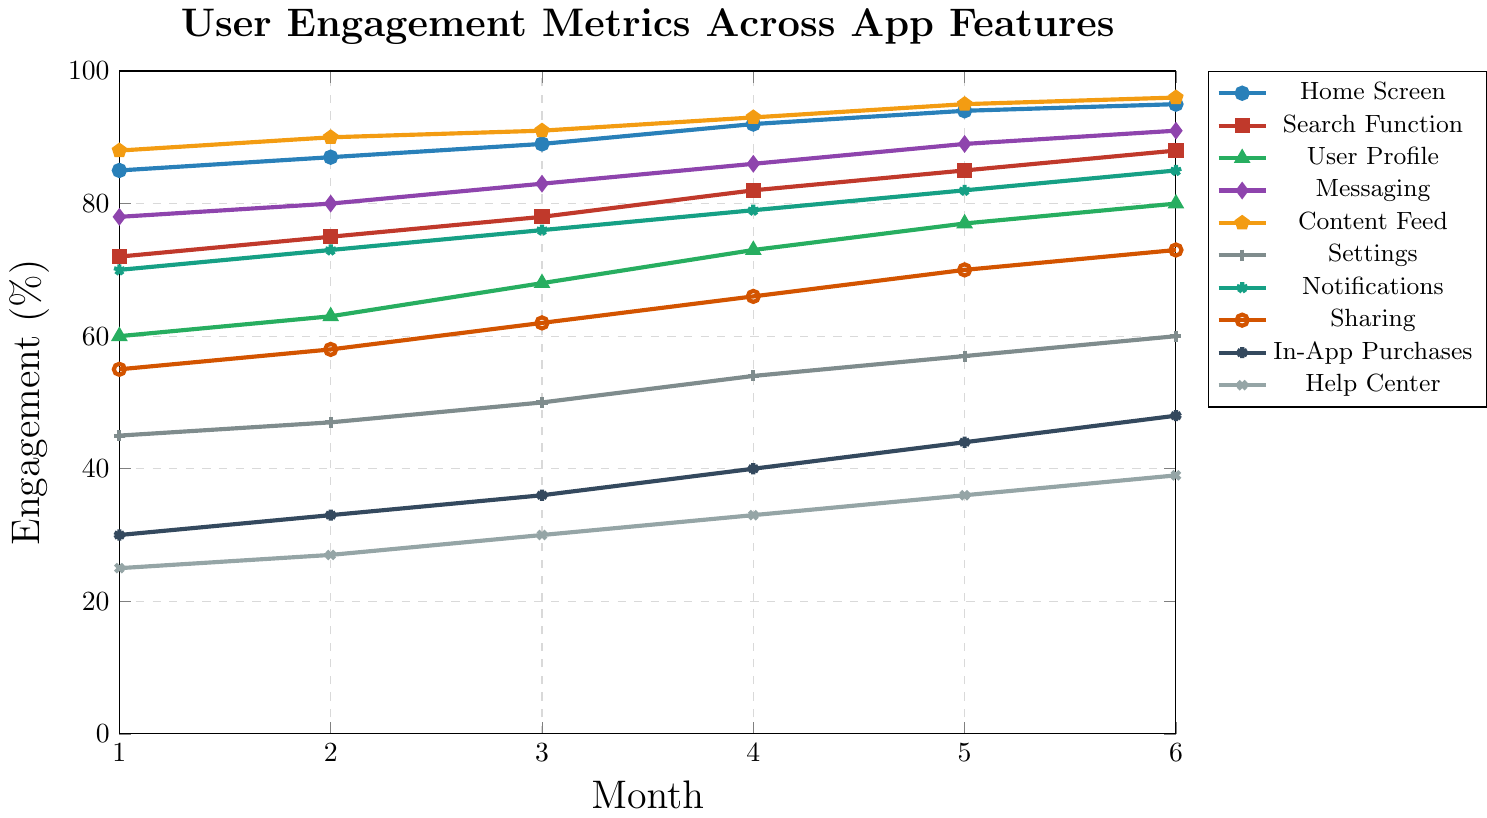What's the highest user engagement percentage recorded for any feature, and which feature does it belong to? The highest engagement percentage shown on the chart is 96%, which corresponds to the Content Feed feature in Month 6. To find this, look for the peak value on the y-axis and match it to the respective feature's line and month.
Answer: 96% Content Feed Which feature shows the largest absolute increase in user engagement from Month 1 to Month 6? To find the feature with the largest absolute increase, calculate the difference between Month 1 and Month 6 for each feature and identify the largest difference: Home Screen: 95-85=10, Search Function: 88-72=16, User Profile: 80-60=20, Messaging: 91-78=13, Content Feed: 96-88=8, Settings: 60-45=15, Notifications: 85-70=15, Sharing: 73-55=18, In-App Purchases: 48-30=18, Help Center: 39-25=14. The User Profile with 20% shows the largest increase.
Answer: User Profile Between Content Feed and Messaging, which feature had a higher user engagement percentage in Month 5, and by how much? Compare the values for Month 5: Content Feed has 95% and Messaging has 89%. Subtract the smaller value from the larger one: 95 - 89 = 6. Thus, Content Feed is higher by 6%.
Answer: Content Feed by 6% What is the average user engagement percentage for the Search function over the 6 months? To find the average, sum the engagement percentages for the Search Function over all 6 months and divide by 6. (72 + 75 + 78 + 82 + 85 + 88) / 6 = 480 / 6 = 80.
Answer: 80% Which feature consistently showed increasing user engagement every month, and what evidence supports this? The Search Function shows a continuous increase each month. Evidence: Month 1 = 72, Month 2 = 75, Month 3 = 78, Month 4 = 82, Month 5 = 85, Month 6 = 88; each month shows an increase over the previous month.
Answer: Search Function Identify the feature with the lowest starting engagement in Month 1 and its value. The lowest starting engagement percentage is for the Help Center feature, which starts at 25%. Scan the values for Month 1 and find the smallest one.
Answer: Help Center at 25% Which two features have the closest user engagement values in Month 4? By comparing the values in Month 4, the Messaging (86%) and Notifications (79%) are closest with a 7% difference. Other values have a larger gap.
Answer: Messaging and Notifications by 7% Calculate the average increase in user engagement per month for Settings. Find the monthly changes and average them: (47-45) = 2, (50-47) = 3, (54-50) = 4, (57-54) = 3, (60-57) = 3. Average = (2+3+4+3+3) / 5 = 15 / 5 = 3.
Answer: 3% Which feature had the steepest decline or least improvement in user engagement from Month 4 to Month 5, and by how much? Subtract Month 4 values from Month 5 values for each feature. The smallest value change is 2% for Home Screen (94-92).
Answer: Home Screen by 2% 